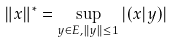Convert formula to latex. <formula><loc_0><loc_0><loc_500><loc_500>\| x \| ^ { * } = \sup _ { y \in E , \| y \| \leq 1 } | ( x | y ) |</formula> 